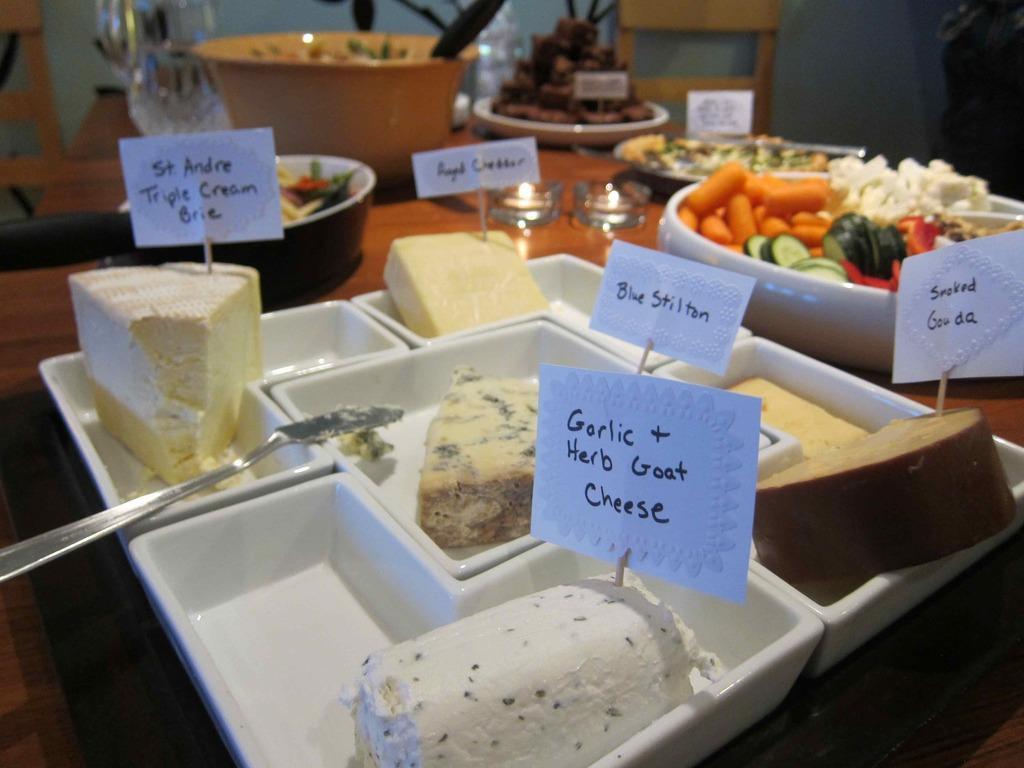Could you give a brief overview of what you see in this image? In this image there is food on the plate and there are vegetables and there are glasses. 